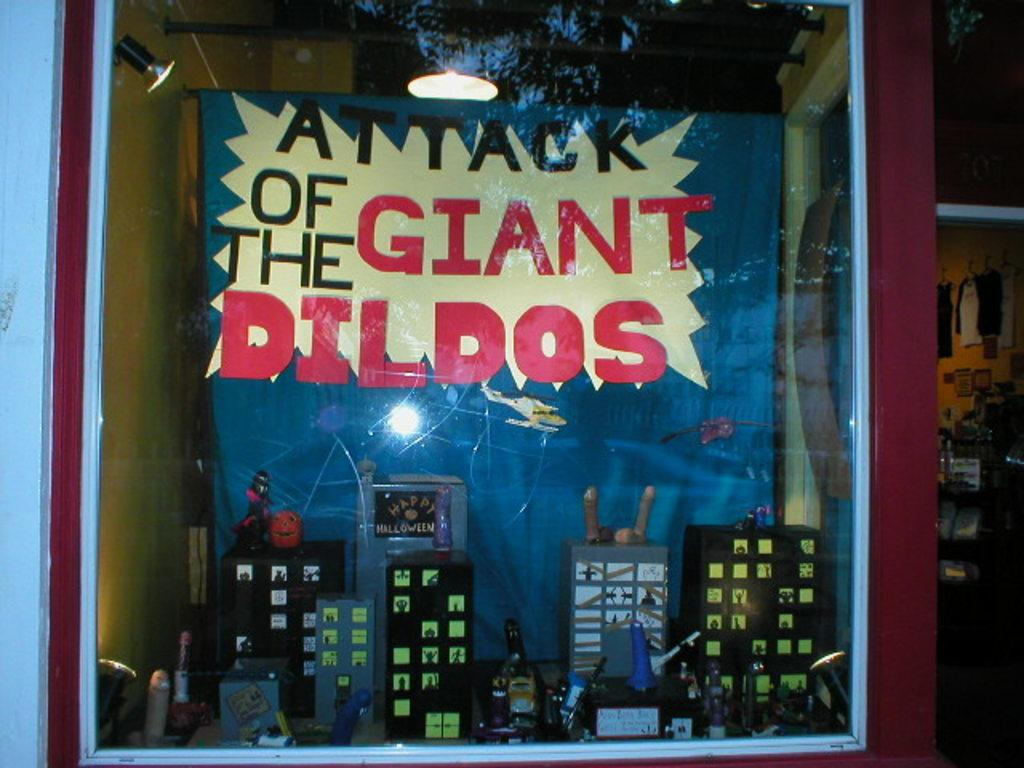Provide a one-sentence caption for the provided image. An art piece of city buildings at night. The art work is called attack of the giant dildos. There different size dildos all over the city. 